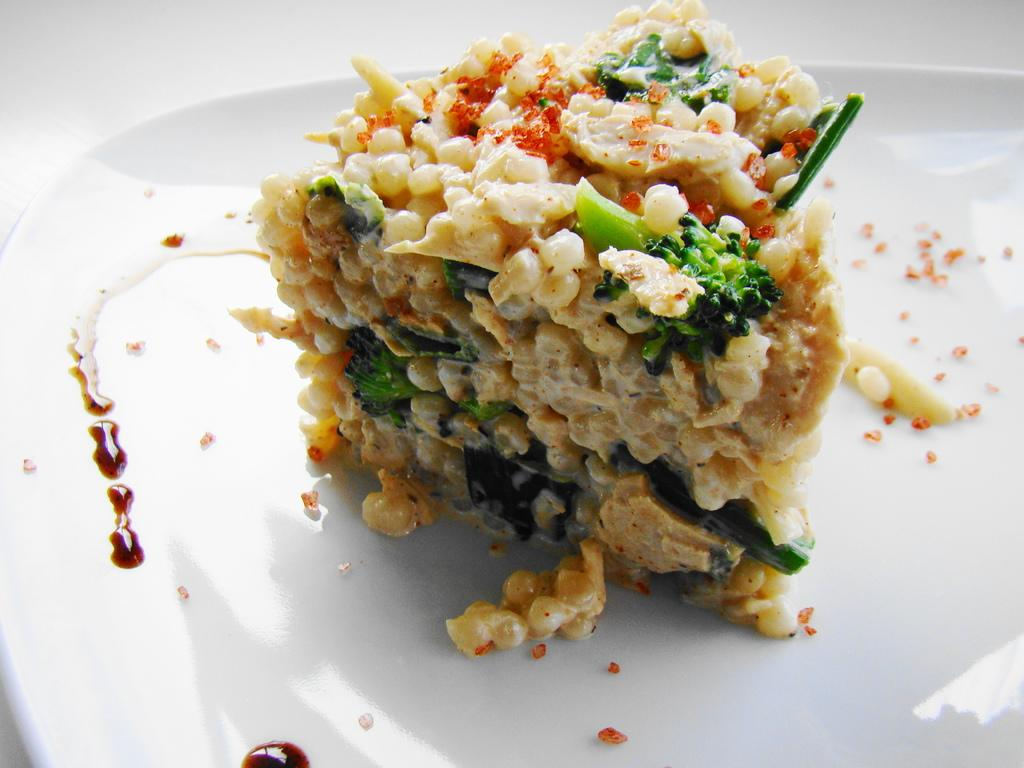What object is present in the image that is used for serving or holding food? There is a plate in the image. What is on the plate in the image? The plate contains food. What is the main ingredient of the food on the plate? The food is made of broccoli. Are there any other ingredients in the food on the plate? Yes, the food contains other ingredients. What type of lace can be seen on the sofa in the image? There is no sofa or lace present in the image; it only features a plate with food. 